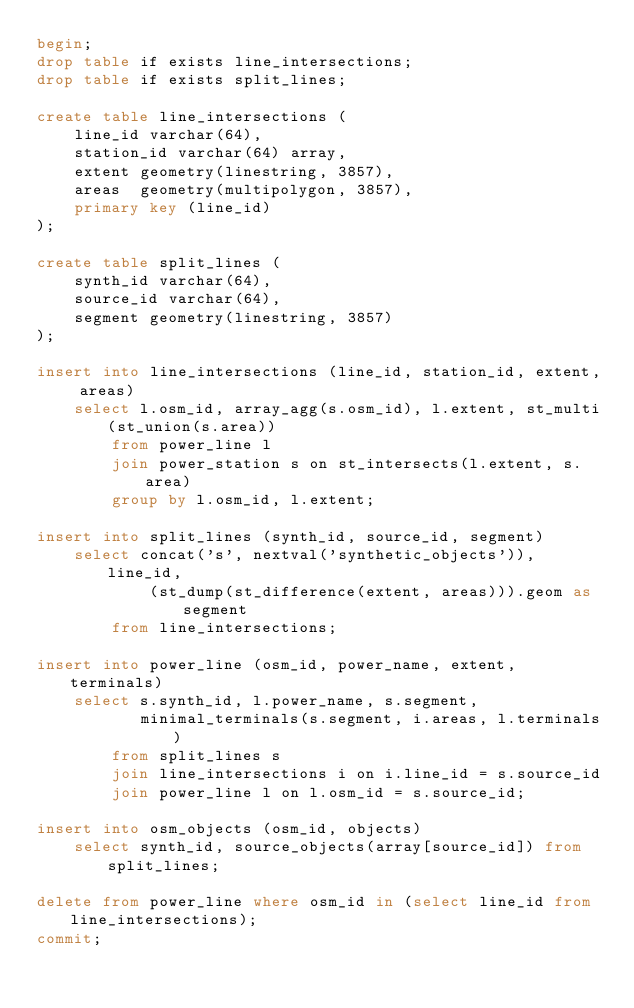Convert code to text. <code><loc_0><loc_0><loc_500><loc_500><_SQL_>begin;
drop table if exists line_intersections;
drop table if exists split_lines;

create table line_intersections (
    line_id varchar(64),
    station_id varchar(64) array,
    extent geometry(linestring, 3857),
    areas  geometry(multipolygon, 3857),
    primary key (line_id)
);

create table split_lines (
    synth_id varchar(64),
    source_id varchar(64),
    segment geometry(linestring, 3857)
);

insert into line_intersections (line_id, station_id, extent, areas)
    select l.osm_id, array_agg(s.osm_id), l.extent, st_multi(st_union(s.area))
        from power_line l
        join power_station s on st_intersects(l.extent, s.area)
        group by l.osm_id, l.extent;

insert into split_lines (synth_id, source_id, segment)
    select concat('s', nextval('synthetic_objects')), line_id,
            (st_dump(st_difference(extent, areas))).geom as segment
        from line_intersections;

insert into power_line (osm_id, power_name, extent, terminals)
    select s.synth_id, l.power_name, s.segment,
           minimal_terminals(s.segment, i.areas, l.terminals)
        from split_lines s
        join line_intersections i on i.line_id = s.source_id
        join power_line l on l.osm_id = s.source_id;

insert into osm_objects (osm_id, objects)
    select synth_id, source_objects(array[source_id]) from split_lines;

delete from power_line where osm_id in (select line_id from line_intersections);
commit;
</code> 